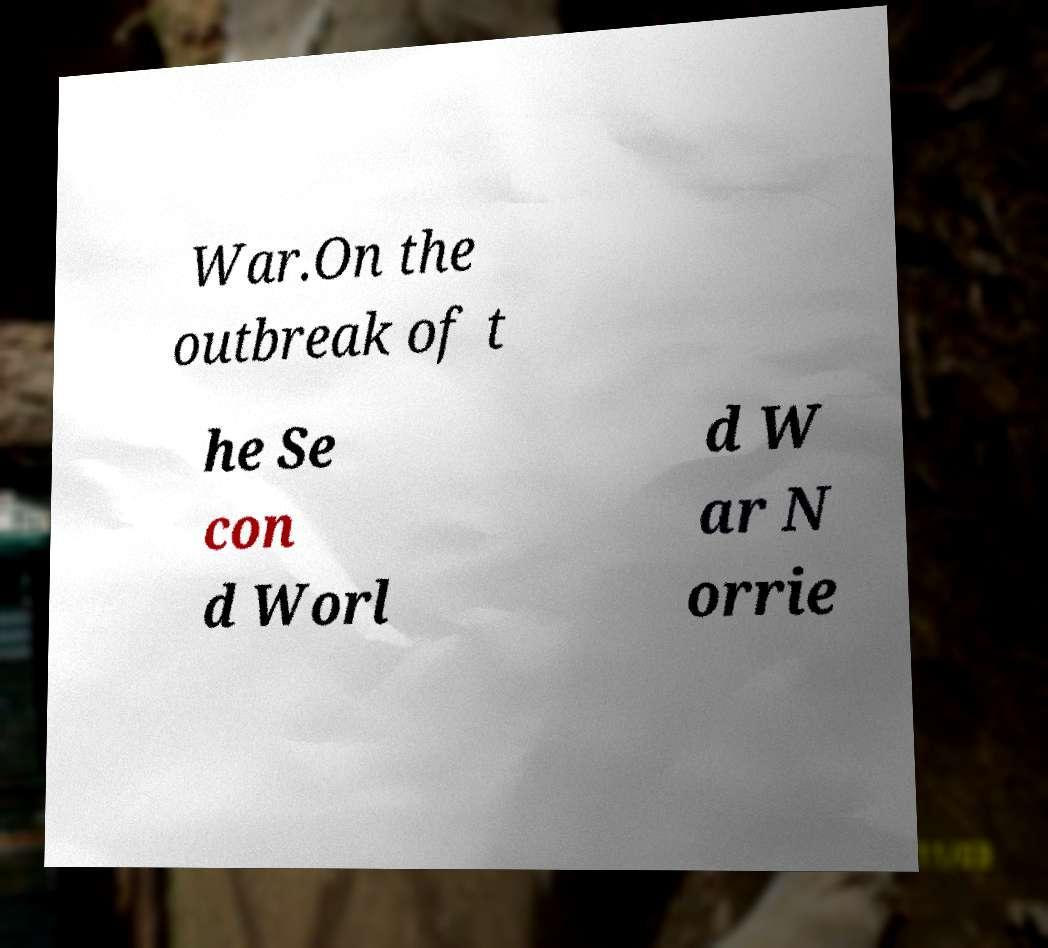I need the written content from this picture converted into text. Can you do that? War.On the outbreak of t he Se con d Worl d W ar N orrie 